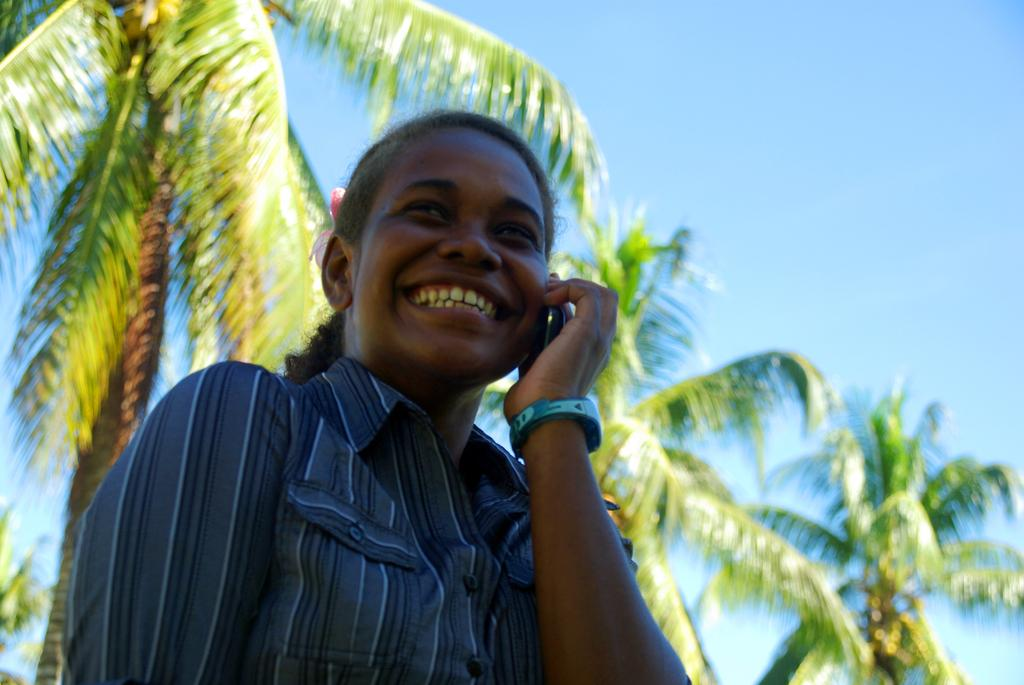What is the main subject of the image? There is a person in the image. What is the person wearing? The person is wearing clothes. What is the person holding in the image? The person is holding a phone. What can be seen in the background of the image? There are trees and the sky visible in the background of the image. How many crows are perched on the person's shoulder in the image? There are no crows present in the image. What season is depicted in the image, considering the presence of spring flowers? The provided facts do not mention any flowers or seasons, so it cannot be determined from the image. 